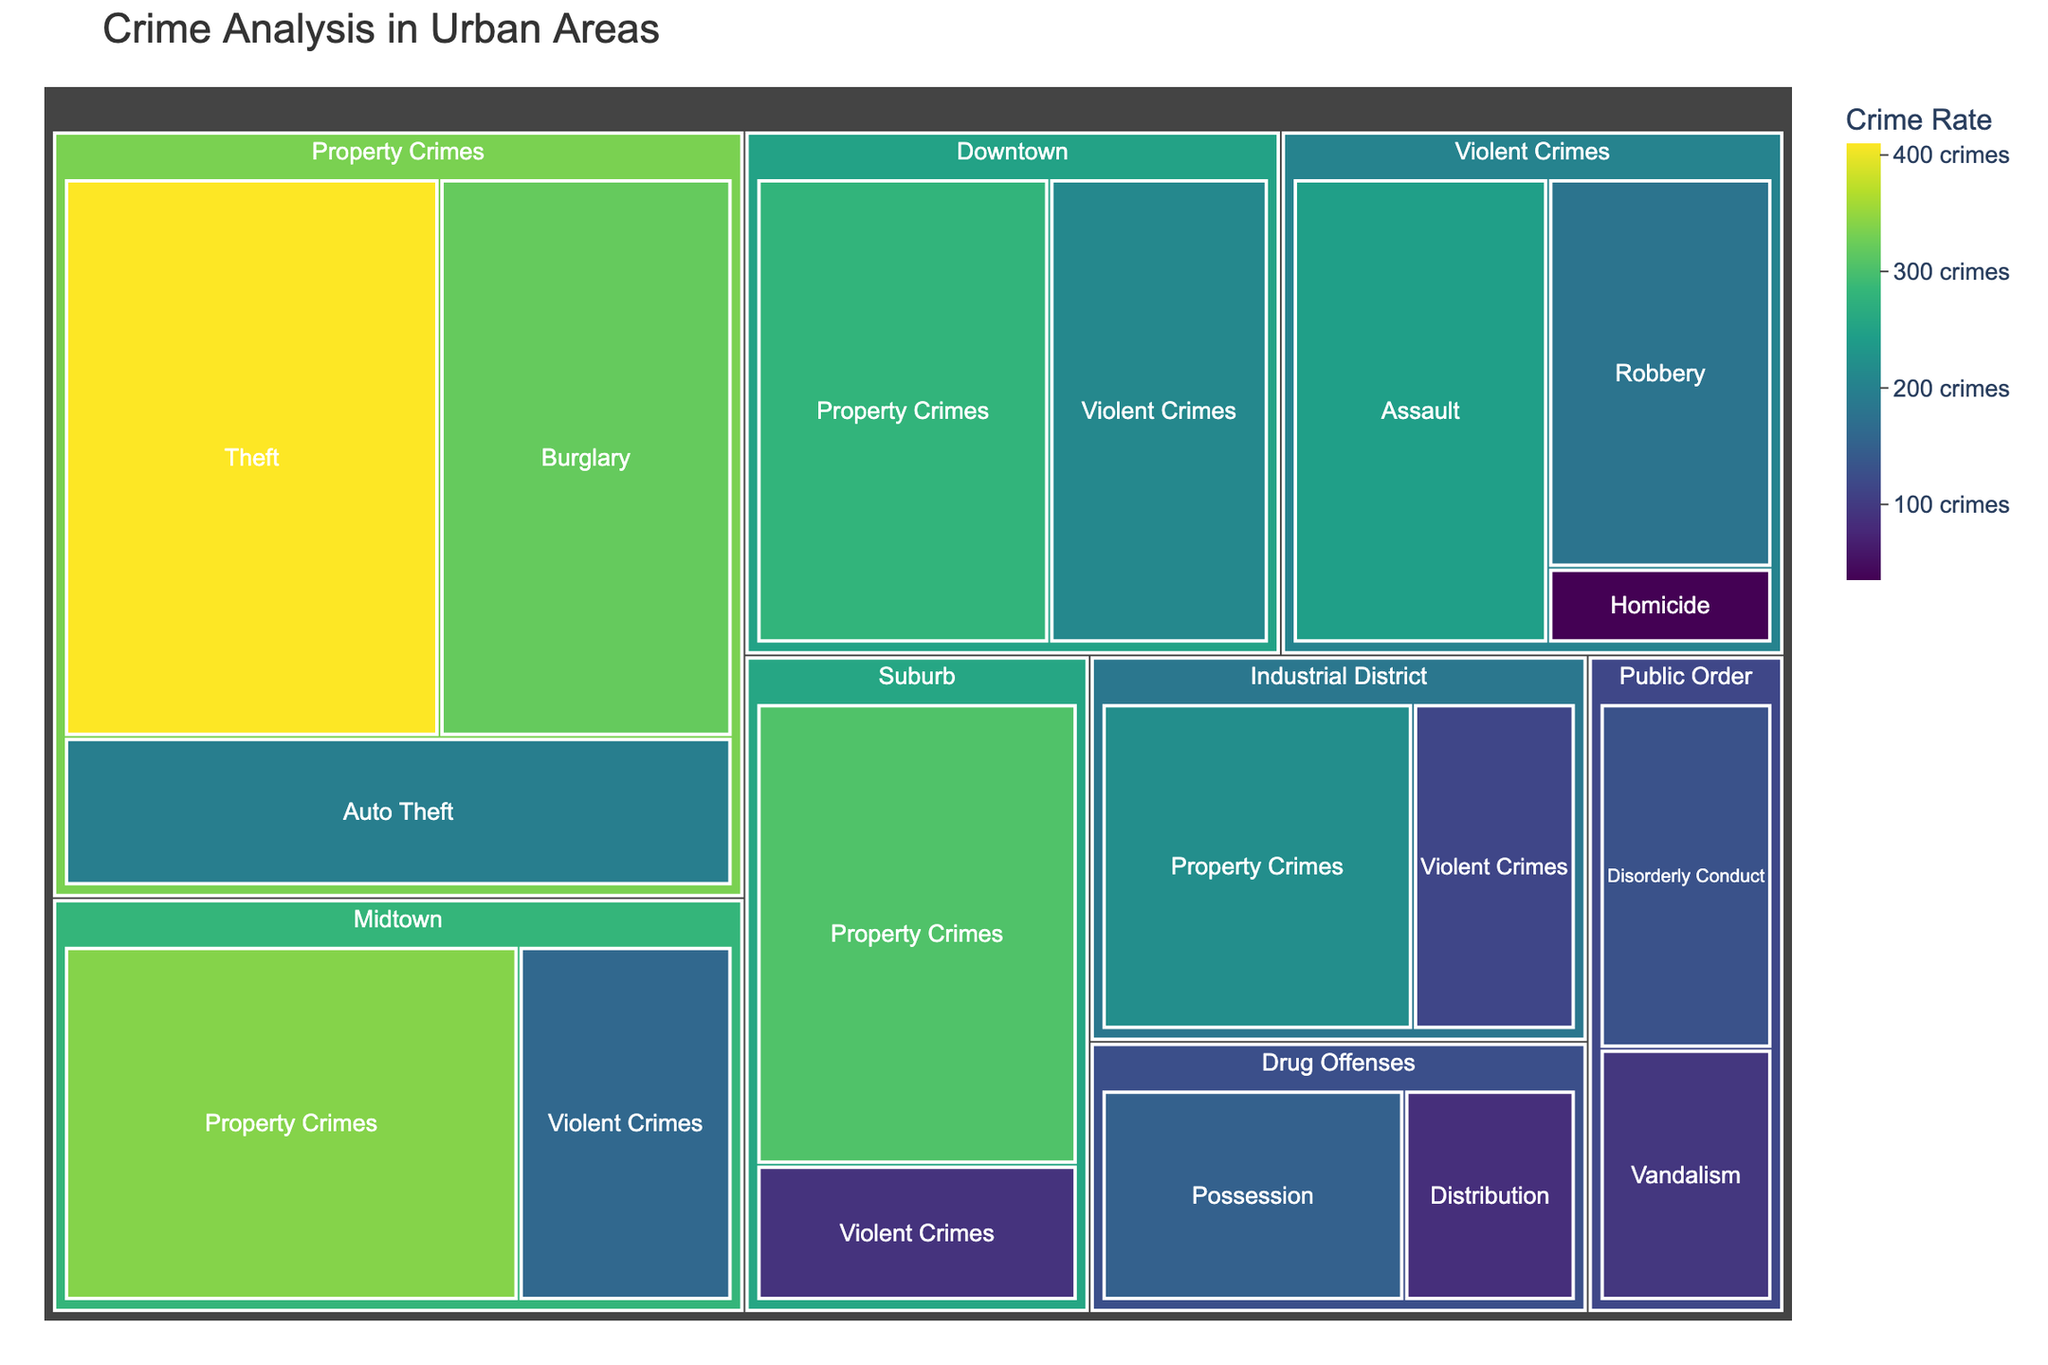What's the total number of Property Crimes? Add the values of all subcategories under Property Crimes: Burglary (320), Theft (410), Auto Theft (195). Total = 320 + 410 + 195
Answer: 925 Which crime has the highest rate? Look for the subcategory with the largest value. Theft under Property Crimes has the highest rate with 410 crimes
Answer: Theft Which neighborhood has the lowest number of Violent Crimes? Compare the values of Violent Crimes across Downtown (210), Midtown (160), Suburb (90), and Industrial District (115). Suburb has the lowest number with 90 crimes
Answer: Suburb What’s the difference between the total number of Violent Crimes and Property Crimes in Midtown? Violent Crimes in Midtown is 160, Property Crimes in Midtown is 340. Difference = 340 - 160
Answer: 180 Which category has fewer crimes: Drug Offenses or Public Order? Sum the subcategories of each category. Drug Offenses (Possession 150 + Distribution 85) = 235, Public Order (Disorderly Conduct 130 + Vandalism 95) = 225. Public Order has fewer crimes
Answer: Public Order What is the combined crime rate for all subcategories under Violent Crimes? Add the values of all subcategories under Violent Crimes: Assault (245), Robbery (180), Homicide (35). Total = 245 + 180 + 35
Answer: 460 Which crime subcategory in Public Order has a higher rate? Compare the values of Disorderly Conduct (130) and Vandalism (95). Disorderly Conduct has a higher rate
Answer: Disorderly Conduct How many more Property Crimes are there in Suburb compared to Industrial District? Property Crimes in Suburb is 305, Property Crimes in Industrial District is 220. Difference = 305 - 220
Answer: 85 Which category shows the highest diversity in crime types based on subcategories? Count the number of subcategories for each main category. Violent Crimes, Property Crimes, Drug Offenses, and Public Order each have 3, 3, 2, and 2 subcategories respectively. Property Crimes and Violent Crimes have the highest diversity with 3 subcategories each
Answer: Property Crimes and Violent Crimes What's the ratio of crimes in Downtown compared to Suburb? Sum the crimes in Downtown (Violent Crimes 210 + Property Crimes 280) = 490, and in Suburb (Violent Crimes 90 + Property Crimes 305) = 395. Ratio = 490/395 = 1.24
Answer: 1.24 